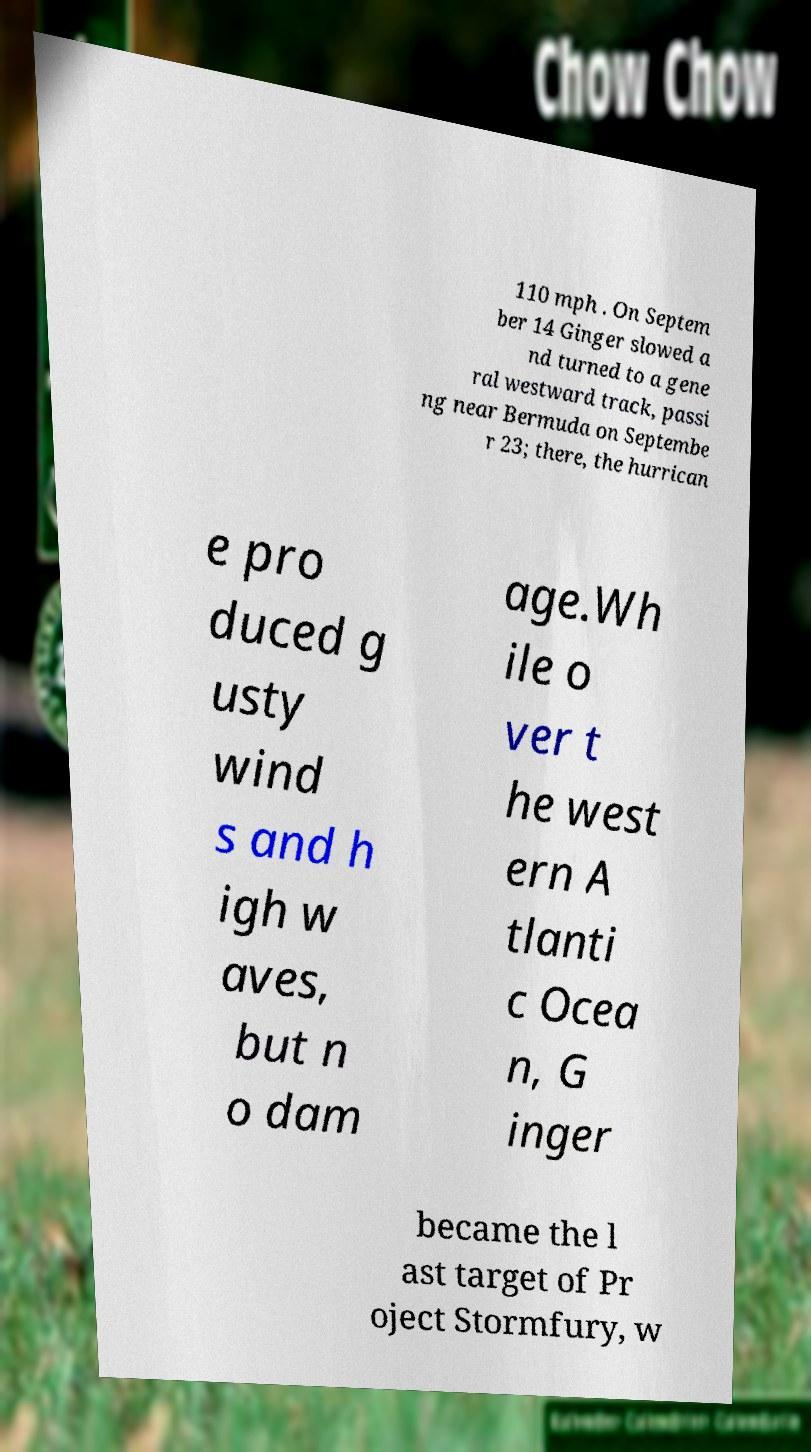For documentation purposes, I need the text within this image transcribed. Could you provide that? 110 mph . On Septem ber 14 Ginger slowed a nd turned to a gene ral westward track, passi ng near Bermuda on Septembe r 23; there, the hurrican e pro duced g usty wind s and h igh w aves, but n o dam age.Wh ile o ver t he west ern A tlanti c Ocea n, G inger became the l ast target of Pr oject Stormfury, w 